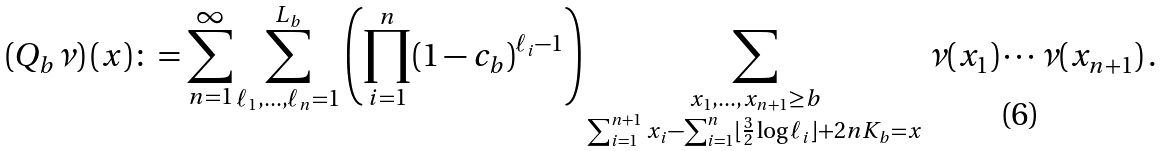Convert formula to latex. <formula><loc_0><loc_0><loc_500><loc_500>\left ( Q _ { b } \nu \right ) ( x ) \colon = \sum _ { n = 1 } ^ { \infty } \sum _ { \ell _ { 1 } , \dots , \ell _ { n } = 1 } ^ { L _ { b } } \left ( \prod _ { i = 1 } ^ { n } ( 1 - c _ { b } ) ^ { \ell _ { i } - 1 } \right ) \sum _ { \substack { x _ { 1 } , \dots , x _ { n + 1 } \geq b \\ \sum _ { i = 1 } ^ { n + 1 } x _ { i } - \sum _ { i = 1 } ^ { n } \lfloor \frac { 3 } { 2 } \log \ell _ { i } \rfloor + 2 n K _ { b } = x } } \nu ( x _ { 1 } ) \cdots \nu ( x _ { n + 1 } ) \, .</formula> 